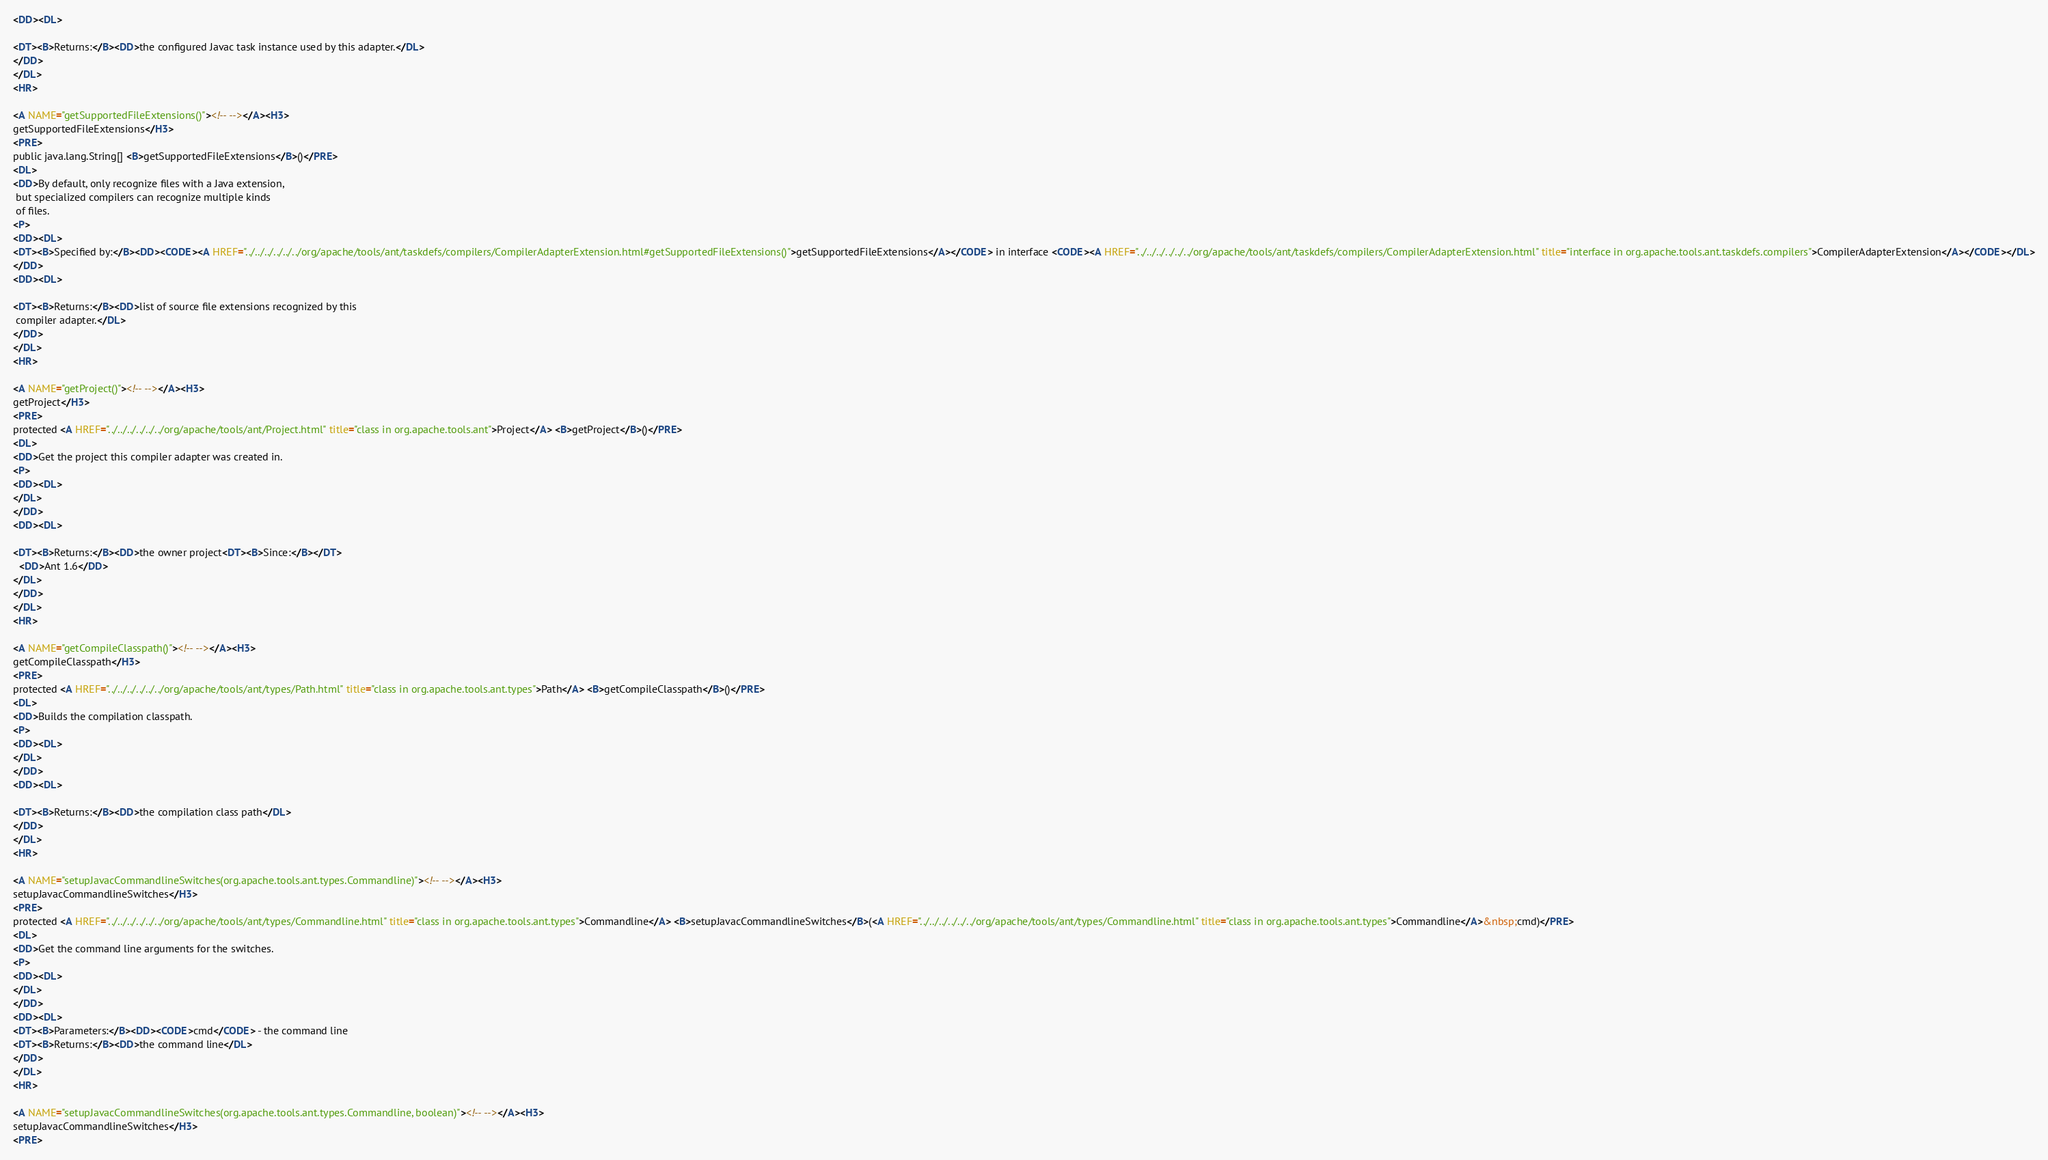Convert code to text. <code><loc_0><loc_0><loc_500><loc_500><_HTML_><DD><DL>

<DT><B>Returns:</B><DD>the configured Javac task instance used by this adapter.</DL>
</DD>
</DL>
<HR>

<A NAME="getSupportedFileExtensions()"><!-- --></A><H3>
getSupportedFileExtensions</H3>
<PRE>
public java.lang.String[] <B>getSupportedFileExtensions</B>()</PRE>
<DL>
<DD>By default, only recognize files with a Java extension,
 but specialized compilers can recognize multiple kinds
 of files.
<P>
<DD><DL>
<DT><B>Specified by:</B><DD><CODE><A HREF="../../../../../../org/apache/tools/ant/taskdefs/compilers/CompilerAdapterExtension.html#getSupportedFileExtensions()">getSupportedFileExtensions</A></CODE> in interface <CODE><A HREF="../../../../../../org/apache/tools/ant/taskdefs/compilers/CompilerAdapterExtension.html" title="interface in org.apache.tools.ant.taskdefs.compilers">CompilerAdapterExtension</A></CODE></DL>
</DD>
<DD><DL>

<DT><B>Returns:</B><DD>list of source file extensions recognized by this
 compiler adapter.</DL>
</DD>
</DL>
<HR>

<A NAME="getProject()"><!-- --></A><H3>
getProject</H3>
<PRE>
protected <A HREF="../../../../../../org/apache/tools/ant/Project.html" title="class in org.apache.tools.ant">Project</A> <B>getProject</B>()</PRE>
<DL>
<DD>Get the project this compiler adapter was created in.
<P>
<DD><DL>
</DL>
</DD>
<DD><DL>

<DT><B>Returns:</B><DD>the owner project<DT><B>Since:</B></DT>
  <DD>Ant 1.6</DD>
</DL>
</DD>
</DL>
<HR>

<A NAME="getCompileClasspath()"><!-- --></A><H3>
getCompileClasspath</H3>
<PRE>
protected <A HREF="../../../../../../org/apache/tools/ant/types/Path.html" title="class in org.apache.tools.ant.types">Path</A> <B>getCompileClasspath</B>()</PRE>
<DL>
<DD>Builds the compilation classpath.
<P>
<DD><DL>
</DL>
</DD>
<DD><DL>

<DT><B>Returns:</B><DD>the compilation class path</DL>
</DD>
</DL>
<HR>

<A NAME="setupJavacCommandlineSwitches(org.apache.tools.ant.types.Commandline)"><!-- --></A><H3>
setupJavacCommandlineSwitches</H3>
<PRE>
protected <A HREF="../../../../../../org/apache/tools/ant/types/Commandline.html" title="class in org.apache.tools.ant.types">Commandline</A> <B>setupJavacCommandlineSwitches</B>(<A HREF="../../../../../../org/apache/tools/ant/types/Commandline.html" title="class in org.apache.tools.ant.types">Commandline</A>&nbsp;cmd)</PRE>
<DL>
<DD>Get the command line arguments for the switches.
<P>
<DD><DL>
</DL>
</DD>
<DD><DL>
<DT><B>Parameters:</B><DD><CODE>cmd</CODE> - the command line
<DT><B>Returns:</B><DD>the command line</DL>
</DD>
</DL>
<HR>

<A NAME="setupJavacCommandlineSwitches(org.apache.tools.ant.types.Commandline, boolean)"><!-- --></A><H3>
setupJavacCommandlineSwitches</H3>
<PRE></code> 